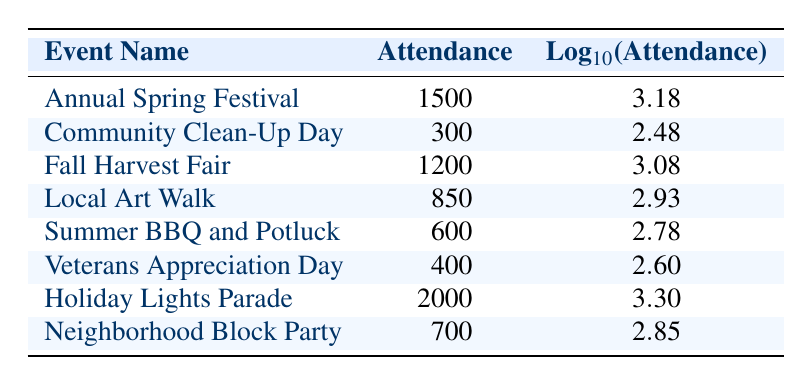What was the attendance at the Holiday Lights Parade? The Holiday Lights Parade row in the table shows the attendance as 2000.
Answer: 2000 Which event had the highest attendance in 2019? The table shows that the Annual Spring Festival had an attendance of 1500, which is the only value for 2019, making it the highest.
Answer: Annual Spring Festival What is the average attendance across all events listed in 2022? The events for 2022 are Summer BBQ and Potluck (600) and Veterans Appreciation Day (400). Adding these gives 1000, and since there are 2 events, the average is 1000/2 = 500.
Answer: 500 Did the attendance at the Local Art Walk exceed 800? The table shows that the attendance was 850, which is greater than 800, confirming the statement as true.
Answer: Yes What was the attendance growth from the Annual Spring Festival in 2019 to the Holiday Lights Parade in 2023? The attendance for the Annual Spring Festival in 2019 was 1500, and for the Holiday Lights Parade in 2023, it was 2000. The growth can be calculated as 2000 - 1500 = 500.
Answer: 500 